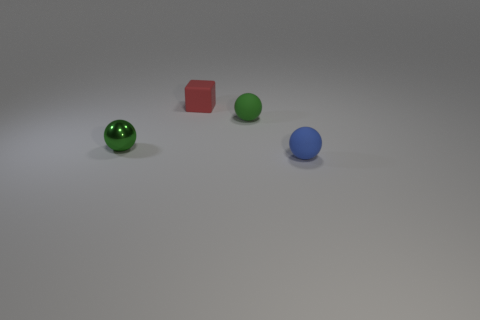The small red thing that is made of the same material as the tiny blue sphere is what shape?
Provide a short and direct response. Cube. Are there more small blue spheres than tiny green things?
Provide a short and direct response. No. Does the small ball left of the small red rubber cube have the same color as the rubber sphere that is behind the blue ball?
Provide a short and direct response. Yes. Does the green sphere that is behind the small shiny thing have the same material as the tiny object that is in front of the small green shiny ball?
Provide a succinct answer. Yes. What number of other red matte cubes have the same size as the cube?
Give a very brief answer. 0. Are there fewer tiny balls than big green shiny spheres?
Offer a terse response. No. There is a rubber thing behind the tiny matte sphere behind the tiny green shiny object; what is its shape?
Offer a terse response. Cube. There is a green rubber object that is the same size as the red rubber cube; what shape is it?
Give a very brief answer. Sphere. Is there a small blue rubber object of the same shape as the green rubber thing?
Your response must be concise. Yes. There is a red matte cube; are there any small red blocks right of it?
Provide a short and direct response. No. 